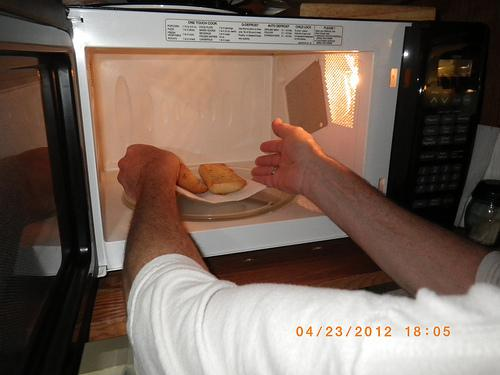Question: what year was this?
Choices:
A. 2009.
B. 1990.
C. 2012.
D. 2002.
Answer with the letter. Answer: C Question: what race is the person?
Choices:
A. White.
B. Black.
C. Asian.
D. Hispanic.
Answer with the letter. Answer: A Question: what food is that?
Choices:
A. Chicken.
B. Cheesecake.
C. Hot Pocket.
D. Pizza.
Answer with the letter. Answer: C Question: what color shirt is he wearing?
Choices:
A. White.
B. Black.
C. Red.
D. Blue.
Answer with the letter. Answer: A Question: what is turned on?
Choices:
A. Television.
B. Light.
C. Cell phone.
D. Fan.
Answer with the letter. Answer: B 